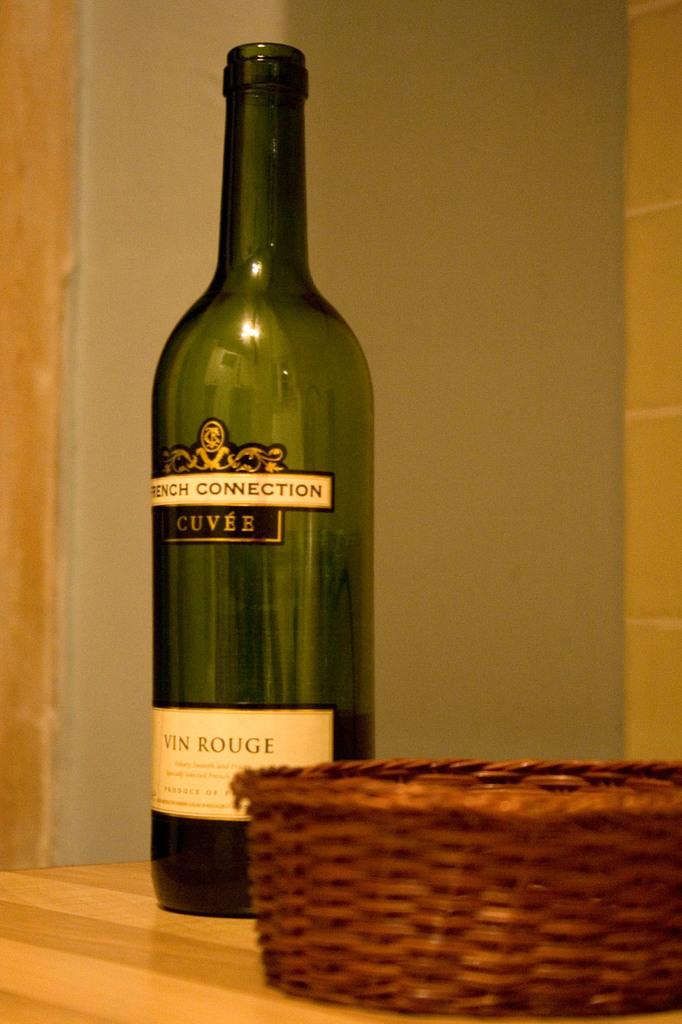What kind of wine is this?
Provide a succinct answer. French connection. What brand is this wine?
Provide a short and direct response. French connection. 